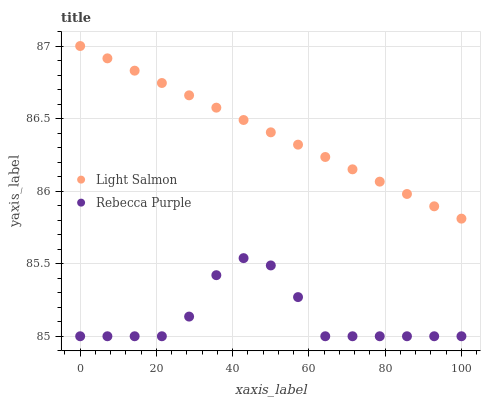Does Rebecca Purple have the minimum area under the curve?
Answer yes or no. Yes. Does Light Salmon have the maximum area under the curve?
Answer yes or no. Yes. Does Rebecca Purple have the maximum area under the curve?
Answer yes or no. No. Is Light Salmon the smoothest?
Answer yes or no. Yes. Is Rebecca Purple the roughest?
Answer yes or no. Yes. Is Rebecca Purple the smoothest?
Answer yes or no. No. Does Rebecca Purple have the lowest value?
Answer yes or no. Yes. Does Light Salmon have the highest value?
Answer yes or no. Yes. Does Rebecca Purple have the highest value?
Answer yes or no. No. Is Rebecca Purple less than Light Salmon?
Answer yes or no. Yes. Is Light Salmon greater than Rebecca Purple?
Answer yes or no. Yes. Does Rebecca Purple intersect Light Salmon?
Answer yes or no. No. 